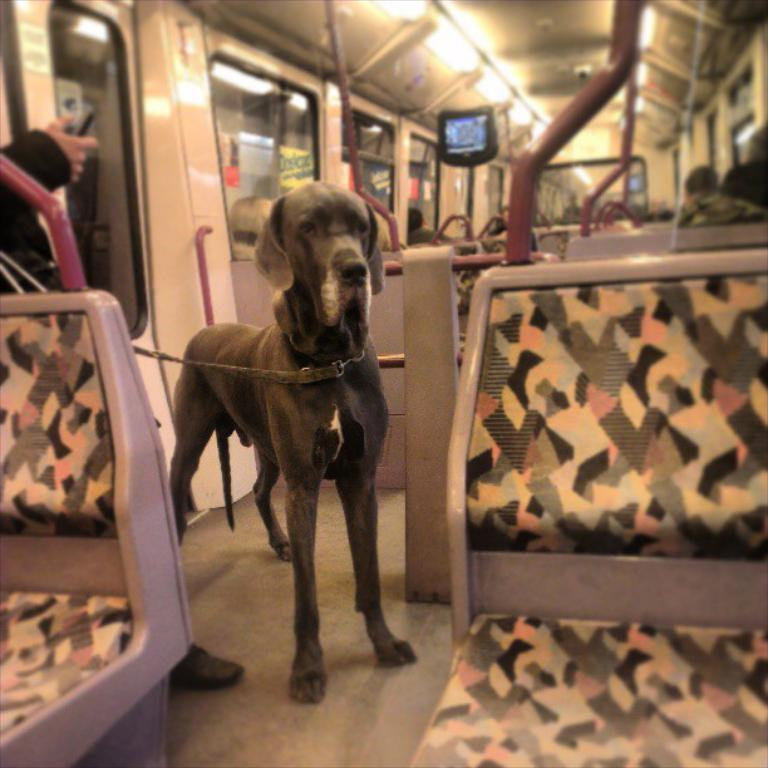What type of animal can be seen in the background of the image? There is a dog in the background of the image. What vertical structure is present in the image? There is a pole in the image. What flat surface is visible in the image? There is a screen in the image. What is located at the top of the image? There is a light at the top of the image. What note is the dog playing on the screen in the image? There is no note or musical instrument present in the image; it features a dog in the background, a pole, a screen, and a light. How does the dog fall from the pole in the image? There is no dog falling from the pole in the image; the dog is in the background, and the pole is a separate object. 